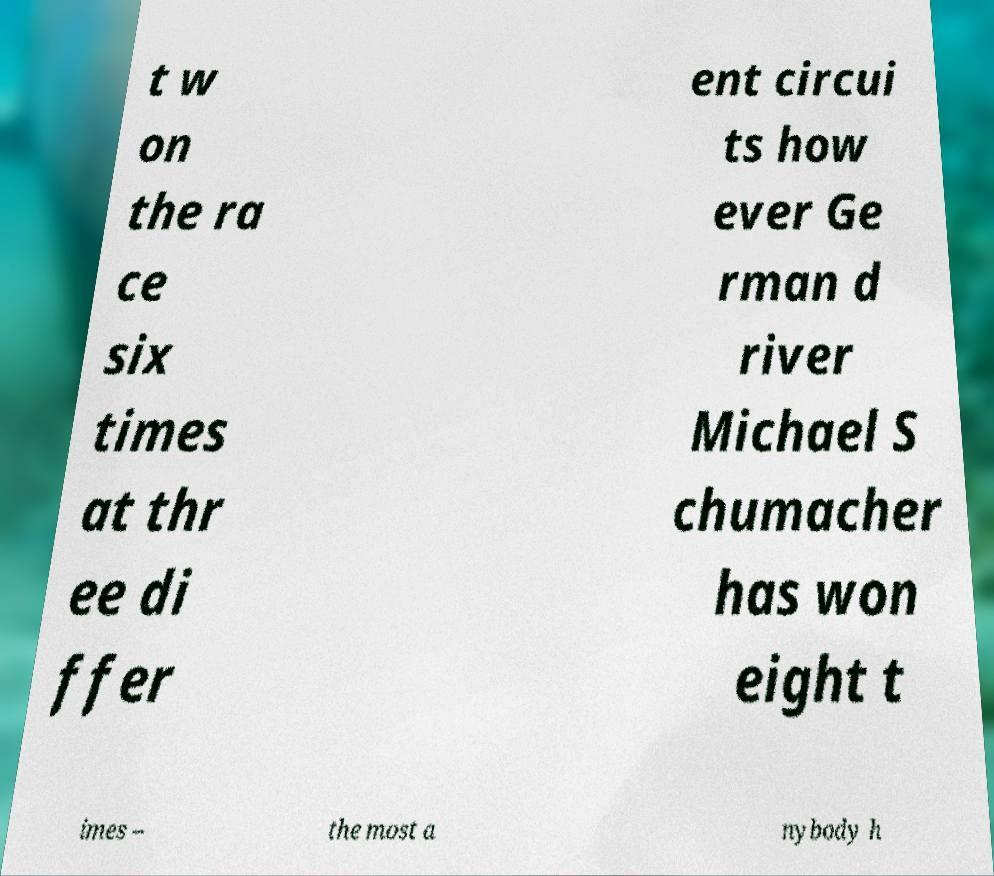I need the written content from this picture converted into text. Can you do that? t w on the ra ce six times at thr ee di ffer ent circui ts how ever Ge rman d river Michael S chumacher has won eight t imes – the most a nybody h 